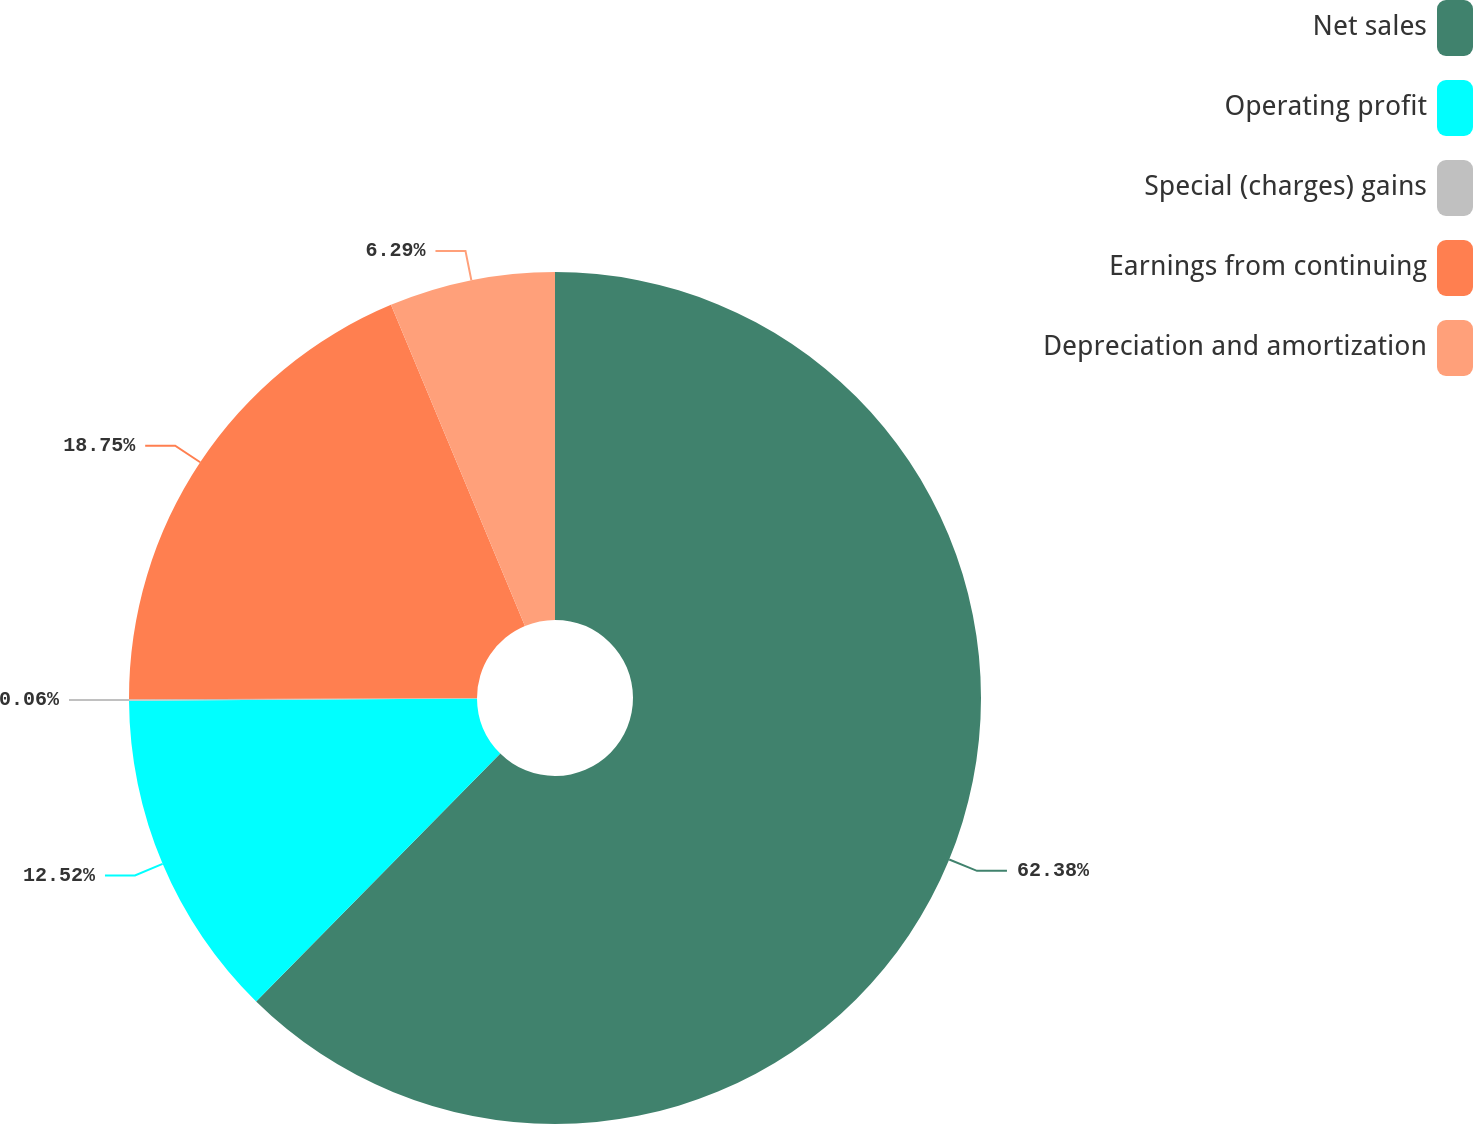Convert chart. <chart><loc_0><loc_0><loc_500><loc_500><pie_chart><fcel>Net sales<fcel>Operating profit<fcel>Special (charges) gains<fcel>Earnings from continuing<fcel>Depreciation and amortization<nl><fcel>62.37%<fcel>12.52%<fcel>0.06%<fcel>18.75%<fcel>6.29%<nl></chart> 